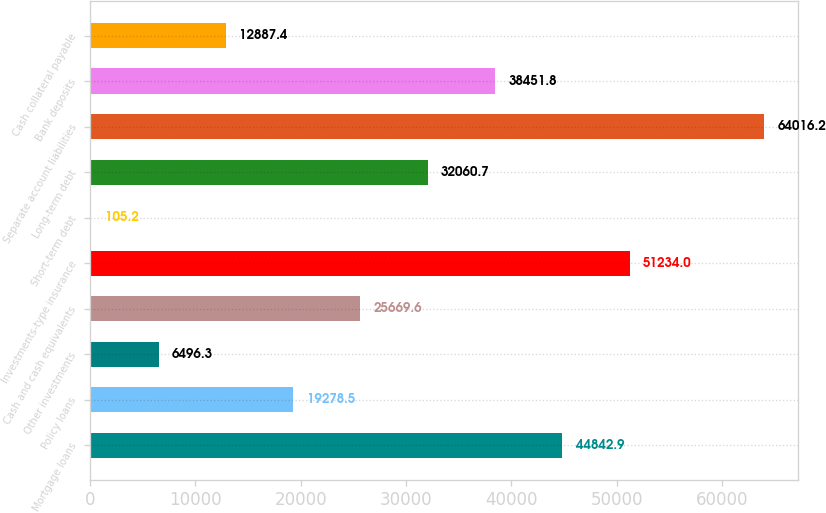Convert chart to OTSL. <chart><loc_0><loc_0><loc_500><loc_500><bar_chart><fcel>Mortgage loans<fcel>Policy loans<fcel>Other investments<fcel>Cash and cash equivalents<fcel>Investments-type insurance<fcel>Short-term debt<fcel>Long-term debt<fcel>Separate account liabilities<fcel>Bank deposits<fcel>Cash collateral payable<nl><fcel>44842.9<fcel>19278.5<fcel>6496.3<fcel>25669.6<fcel>51234<fcel>105.2<fcel>32060.7<fcel>64016.2<fcel>38451.8<fcel>12887.4<nl></chart> 